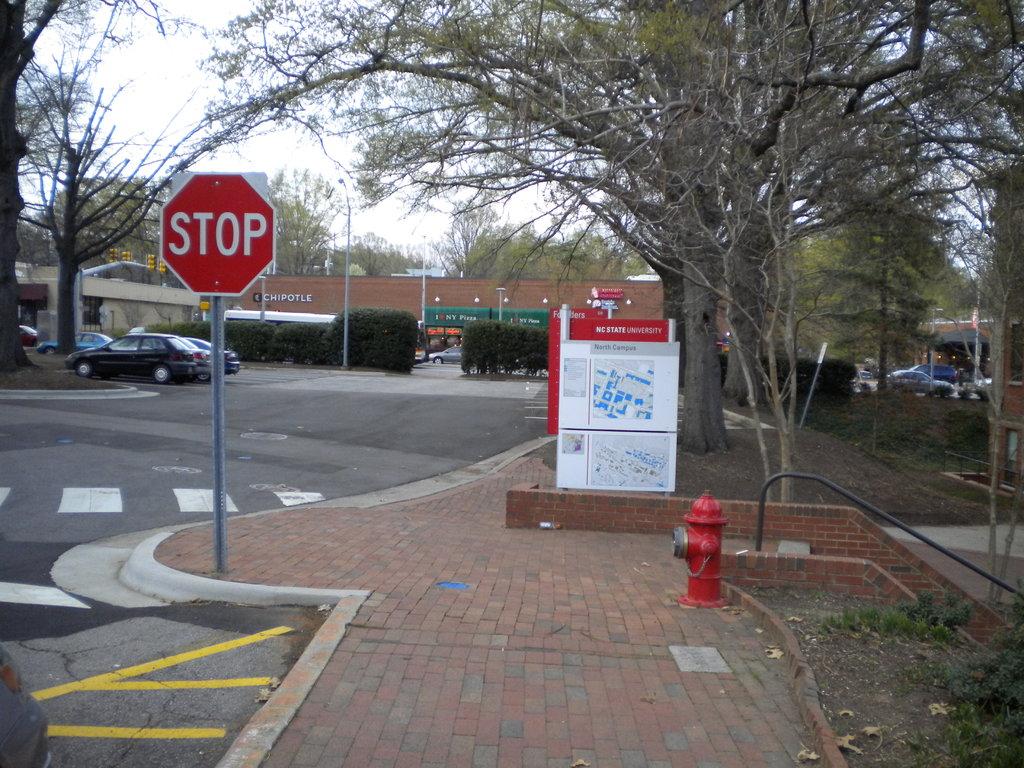What does the red sign tell you to do?
Your answer should be very brief. Stop. 